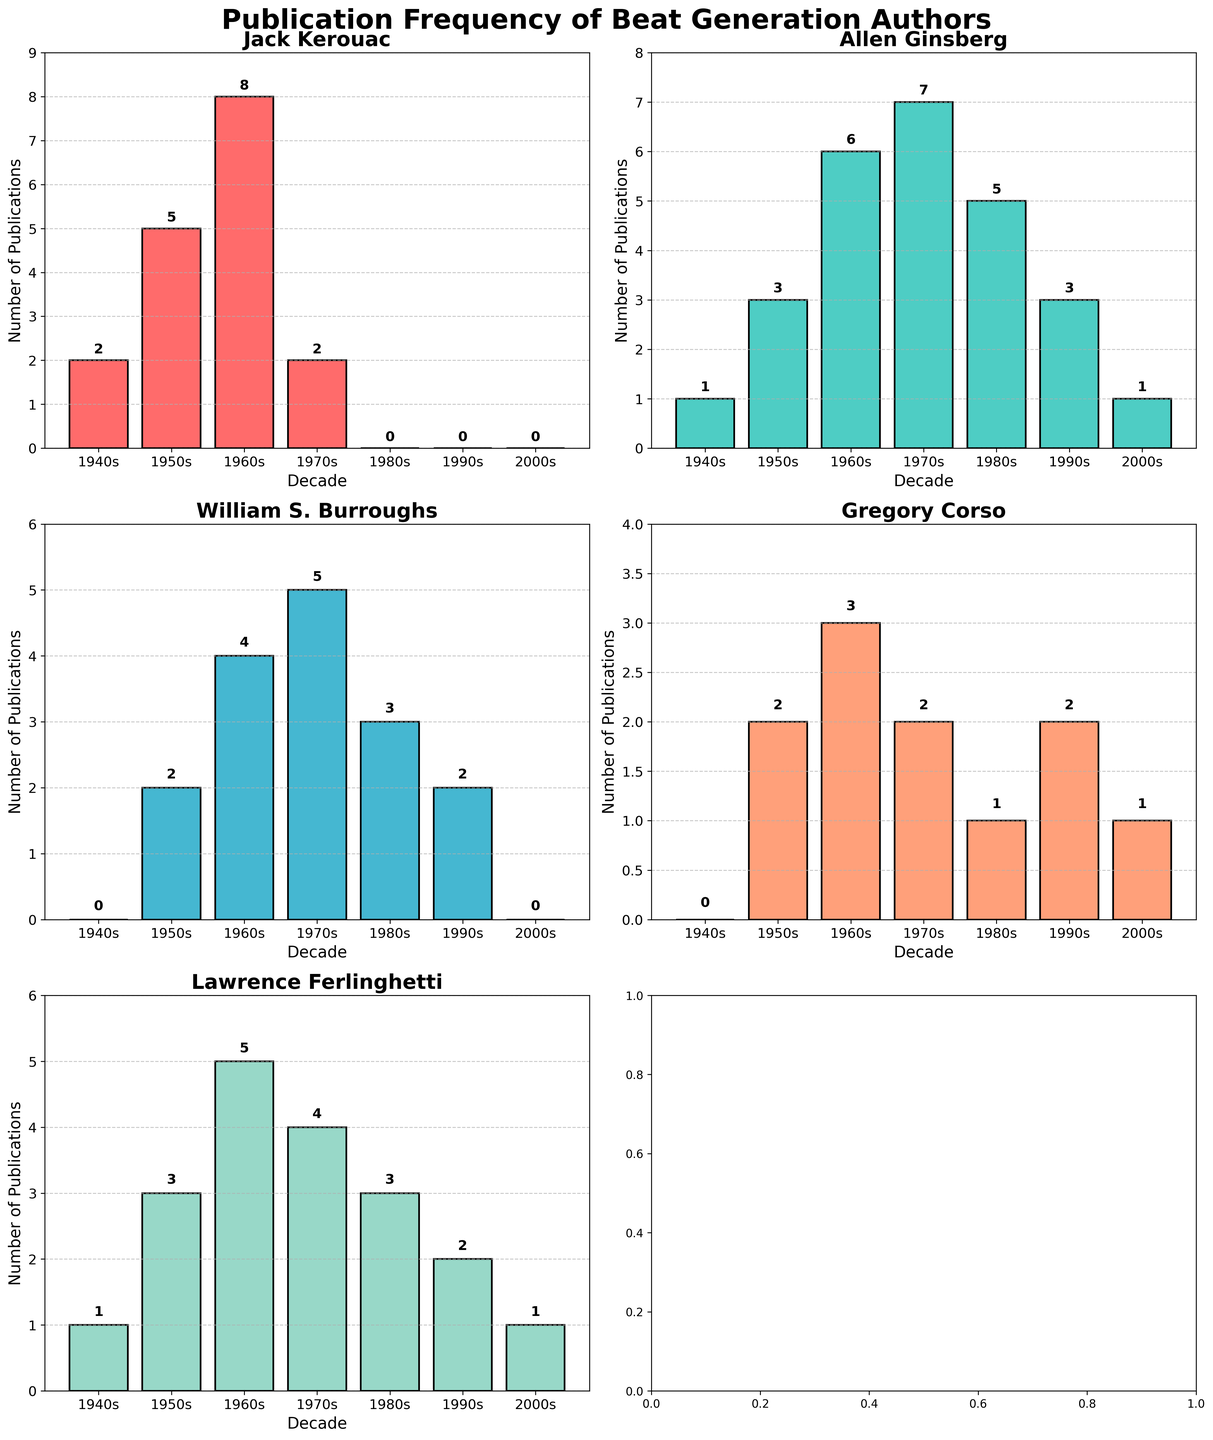How many publications did Allen Ginsberg have in the 1970s? To find Allen Ginsberg's publication frequency in the 1970s, look at his bar on the x-axis label '1970s'. The value indicated by the top of the bar or the text label inside the plot is 7.
Answer: 7 Which author had the highest number of publications in the 1980s? To determine the author with the highest number of publications in the 1980s, compare the height of the bars for each author in the '1980s' column. Allen Ginsberg's bar is the highest, indicating he had the most publications.
Answer: Allen Ginsberg What is the total number of publications by Gregory Corso from the 1940s to the 2000s? Sum up Gregory Corso's publications across all decades: 0 (1940s) + 2 (1950s) + 3 (1960s) + 2 (1970s) + 1 (1980s) + 2 (1990s) + 1 (2000s) = 11.
Answer: 11 Between Jack Kerouac and William S. Burroughs, who had more publications in the 1960s? Compare the publication counts of Jack Kerouac and William S. Burroughs in the 1960s. Jack Kerouac has 8, while William S. Burroughs has 4. Therefore, Jack Kerouac had more publications.
Answer: Jack Kerouac What is the average number of publications for Lawrence Ferlinghetti across all decades shown? Add up all the publications of Lawrence Ferlinghetti: 1 (1940s) + 3 (1950s) + 5 (1960s) + 4 (1970s) + 3 (1980s) + 2 (1990s) + 1 (2000s) = 19. There are 7 decades, so the average is 19 / 7 ≈ 2.71.
Answer: 2.71 Which decade saw the highest number of publications for Jack Kerouac? Examine the bars corresponding to Jack Kerouac across all decades. The highest bar is in the 1960s, with 8 publications.
Answer: 1960s How many more publications did Allen Ginsberg have in the 1960s compared to the 1940s? Compare Allen Ginsberg's publications: 6 (1960s) - 1 (1940s) = 5.
Answer: 5 In which decade did all authors collectively publish the least number of books? Sum the publication counts for all authors in each decade and find the decade with the smallest total. 1940s: 4, 1950s: 15, 1960s: 26, 1970s: 20, 1980s: 12, 1990s: 9, 2000s: 3. The 2000s had the least with 3.
Answer: 2000s 